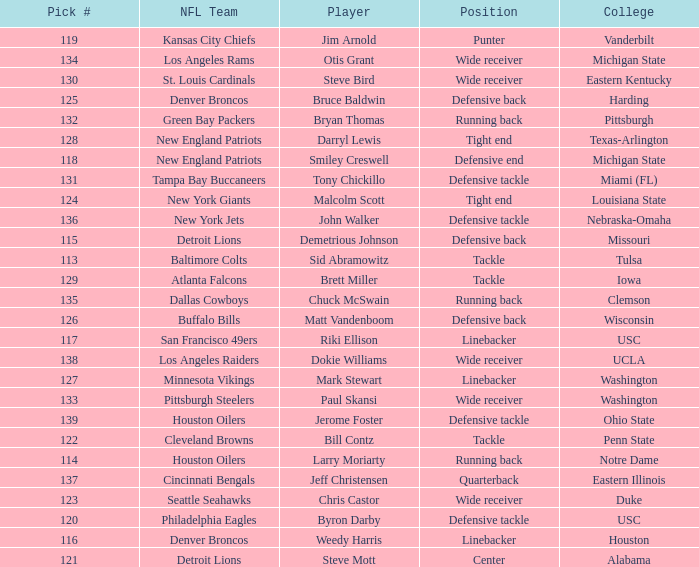What is the highest pick number the los angeles raiders got? 138.0. Would you be able to parse every entry in this table? {'header': ['Pick #', 'NFL Team', 'Player', 'Position', 'College'], 'rows': [['119', 'Kansas City Chiefs', 'Jim Arnold', 'Punter', 'Vanderbilt'], ['134', 'Los Angeles Rams', 'Otis Grant', 'Wide receiver', 'Michigan State'], ['130', 'St. Louis Cardinals', 'Steve Bird', 'Wide receiver', 'Eastern Kentucky'], ['125', 'Denver Broncos', 'Bruce Baldwin', 'Defensive back', 'Harding'], ['132', 'Green Bay Packers', 'Bryan Thomas', 'Running back', 'Pittsburgh'], ['128', 'New England Patriots', 'Darryl Lewis', 'Tight end', 'Texas-Arlington'], ['118', 'New England Patriots', 'Smiley Creswell', 'Defensive end', 'Michigan State'], ['131', 'Tampa Bay Buccaneers', 'Tony Chickillo', 'Defensive tackle', 'Miami (FL)'], ['124', 'New York Giants', 'Malcolm Scott', 'Tight end', 'Louisiana State'], ['136', 'New York Jets', 'John Walker', 'Defensive tackle', 'Nebraska-Omaha'], ['115', 'Detroit Lions', 'Demetrious Johnson', 'Defensive back', 'Missouri'], ['113', 'Baltimore Colts', 'Sid Abramowitz', 'Tackle', 'Tulsa'], ['129', 'Atlanta Falcons', 'Brett Miller', 'Tackle', 'Iowa'], ['135', 'Dallas Cowboys', 'Chuck McSwain', 'Running back', 'Clemson'], ['126', 'Buffalo Bills', 'Matt Vandenboom', 'Defensive back', 'Wisconsin'], ['117', 'San Francisco 49ers', 'Riki Ellison', 'Linebacker', 'USC'], ['138', 'Los Angeles Raiders', 'Dokie Williams', 'Wide receiver', 'UCLA'], ['127', 'Minnesota Vikings', 'Mark Stewart', 'Linebacker', 'Washington'], ['133', 'Pittsburgh Steelers', 'Paul Skansi', 'Wide receiver', 'Washington'], ['139', 'Houston Oilers', 'Jerome Foster', 'Defensive tackle', 'Ohio State'], ['122', 'Cleveland Browns', 'Bill Contz', 'Tackle', 'Penn State'], ['114', 'Houston Oilers', 'Larry Moriarty', 'Running back', 'Notre Dame'], ['137', 'Cincinnati Bengals', 'Jeff Christensen', 'Quarterback', 'Eastern Illinois'], ['123', 'Seattle Seahawks', 'Chris Castor', 'Wide receiver', 'Duke'], ['120', 'Philadelphia Eagles', 'Byron Darby', 'Defensive tackle', 'USC'], ['116', 'Denver Broncos', 'Weedy Harris', 'Linebacker', 'Houston'], ['121', 'Detroit Lions', 'Steve Mott', 'Center', 'Alabama']]} 